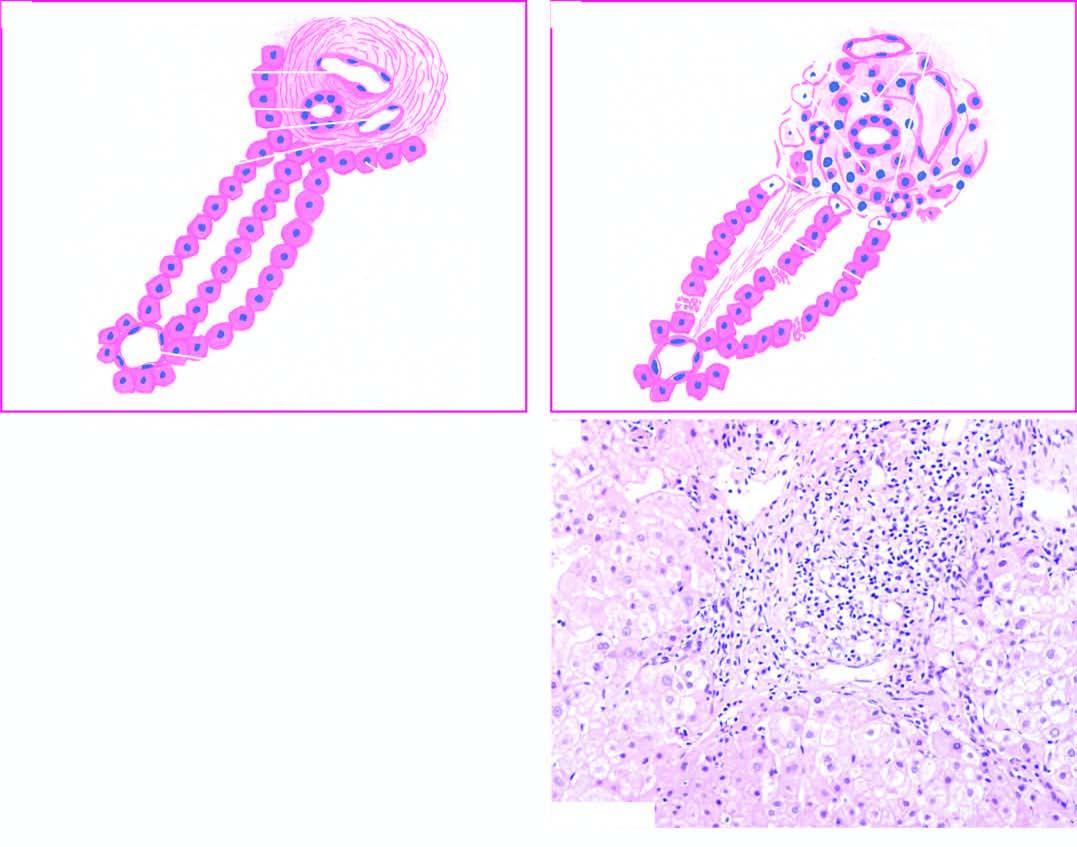what are destroyed?
Answer the question using a single word or phrase. Hepatocytes at the interface of portal tract and lobule 